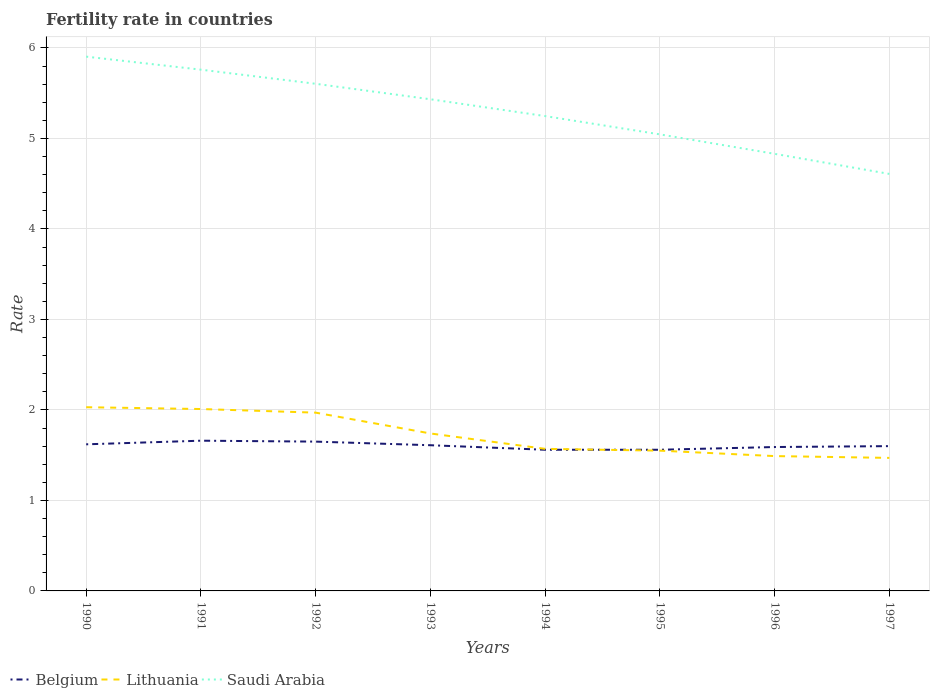How many different coloured lines are there?
Your response must be concise. 3. Across all years, what is the maximum fertility rate in Lithuania?
Your answer should be compact. 1.47. What is the total fertility rate in Saudi Arabia in the graph?
Make the answer very short. 0.47. What is the difference between the highest and the second highest fertility rate in Lithuania?
Your answer should be compact. 0.56. Is the fertility rate in Saudi Arabia strictly greater than the fertility rate in Lithuania over the years?
Your answer should be compact. No. How many years are there in the graph?
Provide a short and direct response. 8. Does the graph contain grids?
Provide a short and direct response. Yes. Where does the legend appear in the graph?
Provide a succinct answer. Bottom left. How are the legend labels stacked?
Provide a succinct answer. Horizontal. What is the title of the graph?
Your answer should be compact. Fertility rate in countries. What is the label or title of the Y-axis?
Give a very brief answer. Rate. What is the Rate of Belgium in 1990?
Your answer should be very brief. 1.62. What is the Rate in Lithuania in 1990?
Provide a short and direct response. 2.03. What is the Rate of Saudi Arabia in 1990?
Your response must be concise. 5.9. What is the Rate of Belgium in 1991?
Offer a terse response. 1.66. What is the Rate in Lithuania in 1991?
Your answer should be compact. 2.01. What is the Rate of Saudi Arabia in 1991?
Your answer should be very brief. 5.76. What is the Rate in Belgium in 1992?
Your answer should be very brief. 1.65. What is the Rate in Lithuania in 1992?
Keep it short and to the point. 1.97. What is the Rate in Saudi Arabia in 1992?
Ensure brevity in your answer.  5.6. What is the Rate in Belgium in 1993?
Make the answer very short. 1.61. What is the Rate of Lithuania in 1993?
Keep it short and to the point. 1.74. What is the Rate in Saudi Arabia in 1993?
Provide a short and direct response. 5.43. What is the Rate in Belgium in 1994?
Offer a very short reply. 1.56. What is the Rate in Lithuania in 1994?
Your answer should be compact. 1.57. What is the Rate in Saudi Arabia in 1994?
Your answer should be compact. 5.25. What is the Rate in Belgium in 1995?
Offer a terse response. 1.56. What is the Rate of Lithuania in 1995?
Provide a succinct answer. 1.55. What is the Rate of Saudi Arabia in 1995?
Provide a short and direct response. 5.04. What is the Rate of Belgium in 1996?
Offer a terse response. 1.59. What is the Rate of Lithuania in 1996?
Your answer should be very brief. 1.49. What is the Rate in Saudi Arabia in 1996?
Offer a terse response. 4.83. What is the Rate in Lithuania in 1997?
Give a very brief answer. 1.47. What is the Rate of Saudi Arabia in 1997?
Offer a very short reply. 4.61. Across all years, what is the maximum Rate in Belgium?
Make the answer very short. 1.66. Across all years, what is the maximum Rate of Lithuania?
Offer a very short reply. 2.03. Across all years, what is the maximum Rate of Saudi Arabia?
Make the answer very short. 5.9. Across all years, what is the minimum Rate of Belgium?
Ensure brevity in your answer.  1.56. Across all years, what is the minimum Rate of Lithuania?
Give a very brief answer. 1.47. Across all years, what is the minimum Rate of Saudi Arabia?
Offer a terse response. 4.61. What is the total Rate in Belgium in the graph?
Make the answer very short. 12.85. What is the total Rate of Lithuania in the graph?
Offer a very short reply. 13.83. What is the total Rate in Saudi Arabia in the graph?
Your answer should be compact. 42.43. What is the difference between the Rate in Belgium in 1990 and that in 1991?
Provide a short and direct response. -0.04. What is the difference between the Rate of Saudi Arabia in 1990 and that in 1991?
Offer a terse response. 0.14. What is the difference between the Rate of Belgium in 1990 and that in 1992?
Provide a succinct answer. -0.03. What is the difference between the Rate of Lithuania in 1990 and that in 1992?
Offer a very short reply. 0.06. What is the difference between the Rate in Belgium in 1990 and that in 1993?
Give a very brief answer. 0.01. What is the difference between the Rate in Lithuania in 1990 and that in 1993?
Offer a terse response. 0.29. What is the difference between the Rate in Saudi Arabia in 1990 and that in 1993?
Provide a short and direct response. 0.47. What is the difference between the Rate in Belgium in 1990 and that in 1994?
Provide a succinct answer. 0.06. What is the difference between the Rate of Lithuania in 1990 and that in 1994?
Give a very brief answer. 0.46. What is the difference between the Rate in Saudi Arabia in 1990 and that in 1994?
Provide a short and direct response. 0.66. What is the difference between the Rate in Belgium in 1990 and that in 1995?
Offer a terse response. 0.06. What is the difference between the Rate in Lithuania in 1990 and that in 1995?
Make the answer very short. 0.48. What is the difference between the Rate of Saudi Arabia in 1990 and that in 1995?
Offer a very short reply. 0.86. What is the difference between the Rate of Lithuania in 1990 and that in 1996?
Your answer should be very brief. 0.54. What is the difference between the Rate in Saudi Arabia in 1990 and that in 1996?
Your response must be concise. 1.07. What is the difference between the Rate of Lithuania in 1990 and that in 1997?
Provide a short and direct response. 0.56. What is the difference between the Rate of Saudi Arabia in 1990 and that in 1997?
Give a very brief answer. 1.3. What is the difference between the Rate in Belgium in 1991 and that in 1992?
Give a very brief answer. 0.01. What is the difference between the Rate of Saudi Arabia in 1991 and that in 1992?
Your answer should be very brief. 0.16. What is the difference between the Rate in Lithuania in 1991 and that in 1993?
Offer a terse response. 0.27. What is the difference between the Rate in Saudi Arabia in 1991 and that in 1993?
Your response must be concise. 0.33. What is the difference between the Rate in Belgium in 1991 and that in 1994?
Offer a terse response. 0.1. What is the difference between the Rate of Lithuania in 1991 and that in 1994?
Ensure brevity in your answer.  0.44. What is the difference between the Rate of Saudi Arabia in 1991 and that in 1994?
Ensure brevity in your answer.  0.51. What is the difference between the Rate in Belgium in 1991 and that in 1995?
Provide a succinct answer. 0.1. What is the difference between the Rate of Lithuania in 1991 and that in 1995?
Give a very brief answer. 0.46. What is the difference between the Rate of Saudi Arabia in 1991 and that in 1995?
Your response must be concise. 0.71. What is the difference between the Rate of Belgium in 1991 and that in 1996?
Your response must be concise. 0.07. What is the difference between the Rate in Lithuania in 1991 and that in 1996?
Offer a terse response. 0.52. What is the difference between the Rate in Saudi Arabia in 1991 and that in 1996?
Make the answer very short. 0.93. What is the difference between the Rate of Lithuania in 1991 and that in 1997?
Offer a terse response. 0.54. What is the difference between the Rate in Saudi Arabia in 1991 and that in 1997?
Offer a terse response. 1.15. What is the difference between the Rate of Belgium in 1992 and that in 1993?
Your response must be concise. 0.04. What is the difference between the Rate in Lithuania in 1992 and that in 1993?
Ensure brevity in your answer.  0.23. What is the difference between the Rate of Saudi Arabia in 1992 and that in 1993?
Offer a terse response. 0.17. What is the difference between the Rate of Belgium in 1992 and that in 1994?
Offer a very short reply. 0.09. What is the difference between the Rate in Lithuania in 1992 and that in 1994?
Your response must be concise. 0.4. What is the difference between the Rate in Saudi Arabia in 1992 and that in 1994?
Offer a terse response. 0.36. What is the difference between the Rate of Belgium in 1992 and that in 1995?
Give a very brief answer. 0.09. What is the difference between the Rate of Lithuania in 1992 and that in 1995?
Keep it short and to the point. 0.42. What is the difference between the Rate of Saudi Arabia in 1992 and that in 1995?
Provide a short and direct response. 0.56. What is the difference between the Rate of Belgium in 1992 and that in 1996?
Offer a terse response. 0.06. What is the difference between the Rate of Lithuania in 1992 and that in 1996?
Your answer should be compact. 0.48. What is the difference between the Rate of Saudi Arabia in 1992 and that in 1996?
Offer a terse response. 0.77. What is the difference between the Rate of Lithuania in 1992 and that in 1997?
Your answer should be very brief. 0.5. What is the difference between the Rate of Lithuania in 1993 and that in 1994?
Your answer should be compact. 0.17. What is the difference between the Rate in Saudi Arabia in 1993 and that in 1994?
Your response must be concise. 0.19. What is the difference between the Rate in Lithuania in 1993 and that in 1995?
Offer a very short reply. 0.19. What is the difference between the Rate in Saudi Arabia in 1993 and that in 1995?
Keep it short and to the point. 0.39. What is the difference between the Rate in Lithuania in 1993 and that in 1996?
Keep it short and to the point. 0.25. What is the difference between the Rate in Saudi Arabia in 1993 and that in 1996?
Give a very brief answer. 0.6. What is the difference between the Rate in Lithuania in 1993 and that in 1997?
Make the answer very short. 0.27. What is the difference between the Rate of Saudi Arabia in 1993 and that in 1997?
Make the answer very short. 0.82. What is the difference between the Rate in Lithuania in 1994 and that in 1995?
Your response must be concise. 0.02. What is the difference between the Rate in Saudi Arabia in 1994 and that in 1995?
Your answer should be very brief. 0.2. What is the difference between the Rate of Belgium in 1994 and that in 1996?
Ensure brevity in your answer.  -0.03. What is the difference between the Rate of Lithuania in 1994 and that in 1996?
Your response must be concise. 0.08. What is the difference between the Rate of Saudi Arabia in 1994 and that in 1996?
Offer a very short reply. 0.42. What is the difference between the Rate in Belgium in 1994 and that in 1997?
Offer a terse response. -0.04. What is the difference between the Rate of Saudi Arabia in 1994 and that in 1997?
Provide a short and direct response. 0.64. What is the difference between the Rate of Belgium in 1995 and that in 1996?
Offer a terse response. -0.03. What is the difference between the Rate of Saudi Arabia in 1995 and that in 1996?
Keep it short and to the point. 0.21. What is the difference between the Rate in Belgium in 1995 and that in 1997?
Ensure brevity in your answer.  -0.04. What is the difference between the Rate in Lithuania in 1995 and that in 1997?
Offer a very short reply. 0.08. What is the difference between the Rate in Saudi Arabia in 1995 and that in 1997?
Make the answer very short. 0.44. What is the difference between the Rate of Belgium in 1996 and that in 1997?
Offer a terse response. -0.01. What is the difference between the Rate in Lithuania in 1996 and that in 1997?
Your answer should be compact. 0.02. What is the difference between the Rate of Saudi Arabia in 1996 and that in 1997?
Offer a very short reply. 0.22. What is the difference between the Rate in Belgium in 1990 and the Rate in Lithuania in 1991?
Make the answer very short. -0.39. What is the difference between the Rate of Belgium in 1990 and the Rate of Saudi Arabia in 1991?
Provide a succinct answer. -4.14. What is the difference between the Rate of Lithuania in 1990 and the Rate of Saudi Arabia in 1991?
Give a very brief answer. -3.73. What is the difference between the Rate of Belgium in 1990 and the Rate of Lithuania in 1992?
Make the answer very short. -0.35. What is the difference between the Rate of Belgium in 1990 and the Rate of Saudi Arabia in 1992?
Your answer should be compact. -3.98. What is the difference between the Rate of Lithuania in 1990 and the Rate of Saudi Arabia in 1992?
Offer a very short reply. -3.57. What is the difference between the Rate in Belgium in 1990 and the Rate in Lithuania in 1993?
Your answer should be compact. -0.12. What is the difference between the Rate in Belgium in 1990 and the Rate in Saudi Arabia in 1993?
Provide a succinct answer. -3.81. What is the difference between the Rate in Lithuania in 1990 and the Rate in Saudi Arabia in 1993?
Your answer should be very brief. -3.4. What is the difference between the Rate in Belgium in 1990 and the Rate in Lithuania in 1994?
Make the answer very short. 0.05. What is the difference between the Rate in Belgium in 1990 and the Rate in Saudi Arabia in 1994?
Keep it short and to the point. -3.63. What is the difference between the Rate in Lithuania in 1990 and the Rate in Saudi Arabia in 1994?
Provide a short and direct response. -3.22. What is the difference between the Rate of Belgium in 1990 and the Rate of Lithuania in 1995?
Provide a short and direct response. 0.07. What is the difference between the Rate of Belgium in 1990 and the Rate of Saudi Arabia in 1995?
Keep it short and to the point. -3.42. What is the difference between the Rate in Lithuania in 1990 and the Rate in Saudi Arabia in 1995?
Your answer should be compact. -3.02. What is the difference between the Rate in Belgium in 1990 and the Rate in Lithuania in 1996?
Offer a terse response. 0.13. What is the difference between the Rate in Belgium in 1990 and the Rate in Saudi Arabia in 1996?
Offer a very short reply. -3.21. What is the difference between the Rate of Belgium in 1990 and the Rate of Saudi Arabia in 1997?
Your answer should be very brief. -2.99. What is the difference between the Rate in Lithuania in 1990 and the Rate in Saudi Arabia in 1997?
Offer a terse response. -2.58. What is the difference between the Rate of Belgium in 1991 and the Rate of Lithuania in 1992?
Ensure brevity in your answer.  -0.31. What is the difference between the Rate of Belgium in 1991 and the Rate of Saudi Arabia in 1992?
Provide a short and direct response. -3.94. What is the difference between the Rate in Lithuania in 1991 and the Rate in Saudi Arabia in 1992?
Your answer should be compact. -3.59. What is the difference between the Rate of Belgium in 1991 and the Rate of Lithuania in 1993?
Your answer should be very brief. -0.08. What is the difference between the Rate of Belgium in 1991 and the Rate of Saudi Arabia in 1993?
Your answer should be compact. -3.77. What is the difference between the Rate in Lithuania in 1991 and the Rate in Saudi Arabia in 1993?
Keep it short and to the point. -3.42. What is the difference between the Rate in Belgium in 1991 and the Rate in Lithuania in 1994?
Keep it short and to the point. 0.09. What is the difference between the Rate of Belgium in 1991 and the Rate of Saudi Arabia in 1994?
Keep it short and to the point. -3.59. What is the difference between the Rate in Lithuania in 1991 and the Rate in Saudi Arabia in 1994?
Ensure brevity in your answer.  -3.24. What is the difference between the Rate in Belgium in 1991 and the Rate in Lithuania in 1995?
Your answer should be very brief. 0.11. What is the difference between the Rate in Belgium in 1991 and the Rate in Saudi Arabia in 1995?
Offer a very short reply. -3.38. What is the difference between the Rate in Lithuania in 1991 and the Rate in Saudi Arabia in 1995?
Your answer should be compact. -3.04. What is the difference between the Rate of Belgium in 1991 and the Rate of Lithuania in 1996?
Your answer should be very brief. 0.17. What is the difference between the Rate of Belgium in 1991 and the Rate of Saudi Arabia in 1996?
Your answer should be compact. -3.17. What is the difference between the Rate of Lithuania in 1991 and the Rate of Saudi Arabia in 1996?
Ensure brevity in your answer.  -2.82. What is the difference between the Rate in Belgium in 1991 and the Rate in Lithuania in 1997?
Your response must be concise. 0.19. What is the difference between the Rate in Belgium in 1991 and the Rate in Saudi Arabia in 1997?
Keep it short and to the point. -2.95. What is the difference between the Rate in Lithuania in 1991 and the Rate in Saudi Arabia in 1997?
Offer a very short reply. -2.6. What is the difference between the Rate of Belgium in 1992 and the Rate of Lithuania in 1993?
Offer a terse response. -0.09. What is the difference between the Rate in Belgium in 1992 and the Rate in Saudi Arabia in 1993?
Ensure brevity in your answer.  -3.78. What is the difference between the Rate in Lithuania in 1992 and the Rate in Saudi Arabia in 1993?
Offer a very short reply. -3.46. What is the difference between the Rate in Belgium in 1992 and the Rate in Saudi Arabia in 1994?
Your answer should be very brief. -3.6. What is the difference between the Rate in Lithuania in 1992 and the Rate in Saudi Arabia in 1994?
Your response must be concise. -3.28. What is the difference between the Rate of Belgium in 1992 and the Rate of Lithuania in 1995?
Your response must be concise. 0.1. What is the difference between the Rate of Belgium in 1992 and the Rate of Saudi Arabia in 1995?
Give a very brief answer. -3.4. What is the difference between the Rate of Lithuania in 1992 and the Rate of Saudi Arabia in 1995?
Offer a very short reply. -3.08. What is the difference between the Rate in Belgium in 1992 and the Rate in Lithuania in 1996?
Give a very brief answer. 0.16. What is the difference between the Rate in Belgium in 1992 and the Rate in Saudi Arabia in 1996?
Provide a succinct answer. -3.18. What is the difference between the Rate in Lithuania in 1992 and the Rate in Saudi Arabia in 1996?
Your answer should be very brief. -2.86. What is the difference between the Rate in Belgium in 1992 and the Rate in Lithuania in 1997?
Your answer should be compact. 0.18. What is the difference between the Rate in Belgium in 1992 and the Rate in Saudi Arabia in 1997?
Provide a succinct answer. -2.96. What is the difference between the Rate of Lithuania in 1992 and the Rate of Saudi Arabia in 1997?
Ensure brevity in your answer.  -2.64. What is the difference between the Rate in Belgium in 1993 and the Rate in Lithuania in 1994?
Ensure brevity in your answer.  0.04. What is the difference between the Rate in Belgium in 1993 and the Rate in Saudi Arabia in 1994?
Your answer should be very brief. -3.64. What is the difference between the Rate of Lithuania in 1993 and the Rate of Saudi Arabia in 1994?
Your answer should be very brief. -3.51. What is the difference between the Rate in Belgium in 1993 and the Rate in Saudi Arabia in 1995?
Your answer should be very brief. -3.44. What is the difference between the Rate in Lithuania in 1993 and the Rate in Saudi Arabia in 1995?
Give a very brief answer. -3.31. What is the difference between the Rate of Belgium in 1993 and the Rate of Lithuania in 1996?
Your answer should be compact. 0.12. What is the difference between the Rate of Belgium in 1993 and the Rate of Saudi Arabia in 1996?
Provide a succinct answer. -3.22. What is the difference between the Rate of Lithuania in 1993 and the Rate of Saudi Arabia in 1996?
Give a very brief answer. -3.09. What is the difference between the Rate of Belgium in 1993 and the Rate of Lithuania in 1997?
Your answer should be very brief. 0.14. What is the difference between the Rate of Belgium in 1993 and the Rate of Saudi Arabia in 1997?
Offer a very short reply. -3. What is the difference between the Rate of Lithuania in 1993 and the Rate of Saudi Arabia in 1997?
Your response must be concise. -2.87. What is the difference between the Rate in Belgium in 1994 and the Rate in Saudi Arabia in 1995?
Make the answer very short. -3.48. What is the difference between the Rate of Lithuania in 1994 and the Rate of Saudi Arabia in 1995?
Your response must be concise. -3.48. What is the difference between the Rate of Belgium in 1994 and the Rate of Lithuania in 1996?
Make the answer very short. 0.07. What is the difference between the Rate of Belgium in 1994 and the Rate of Saudi Arabia in 1996?
Provide a short and direct response. -3.27. What is the difference between the Rate of Lithuania in 1994 and the Rate of Saudi Arabia in 1996?
Your answer should be very brief. -3.26. What is the difference between the Rate in Belgium in 1994 and the Rate in Lithuania in 1997?
Provide a short and direct response. 0.09. What is the difference between the Rate in Belgium in 1994 and the Rate in Saudi Arabia in 1997?
Your answer should be very brief. -3.05. What is the difference between the Rate of Lithuania in 1994 and the Rate of Saudi Arabia in 1997?
Your answer should be compact. -3.04. What is the difference between the Rate in Belgium in 1995 and the Rate in Lithuania in 1996?
Provide a succinct answer. 0.07. What is the difference between the Rate in Belgium in 1995 and the Rate in Saudi Arabia in 1996?
Your answer should be compact. -3.27. What is the difference between the Rate in Lithuania in 1995 and the Rate in Saudi Arabia in 1996?
Provide a succinct answer. -3.28. What is the difference between the Rate of Belgium in 1995 and the Rate of Lithuania in 1997?
Give a very brief answer. 0.09. What is the difference between the Rate in Belgium in 1995 and the Rate in Saudi Arabia in 1997?
Provide a short and direct response. -3.05. What is the difference between the Rate in Lithuania in 1995 and the Rate in Saudi Arabia in 1997?
Offer a terse response. -3.06. What is the difference between the Rate in Belgium in 1996 and the Rate in Lithuania in 1997?
Your answer should be very brief. 0.12. What is the difference between the Rate of Belgium in 1996 and the Rate of Saudi Arabia in 1997?
Provide a short and direct response. -3.02. What is the difference between the Rate in Lithuania in 1996 and the Rate in Saudi Arabia in 1997?
Offer a terse response. -3.12. What is the average Rate of Belgium per year?
Offer a terse response. 1.61. What is the average Rate in Lithuania per year?
Make the answer very short. 1.73. What is the average Rate in Saudi Arabia per year?
Make the answer very short. 5.3. In the year 1990, what is the difference between the Rate of Belgium and Rate of Lithuania?
Make the answer very short. -0.41. In the year 1990, what is the difference between the Rate of Belgium and Rate of Saudi Arabia?
Provide a short and direct response. -4.28. In the year 1990, what is the difference between the Rate of Lithuania and Rate of Saudi Arabia?
Provide a short and direct response. -3.87. In the year 1991, what is the difference between the Rate in Belgium and Rate in Lithuania?
Ensure brevity in your answer.  -0.35. In the year 1991, what is the difference between the Rate of Lithuania and Rate of Saudi Arabia?
Ensure brevity in your answer.  -3.75. In the year 1992, what is the difference between the Rate of Belgium and Rate of Lithuania?
Offer a terse response. -0.32. In the year 1992, what is the difference between the Rate in Belgium and Rate in Saudi Arabia?
Provide a succinct answer. -3.95. In the year 1992, what is the difference between the Rate of Lithuania and Rate of Saudi Arabia?
Your answer should be very brief. -3.63. In the year 1993, what is the difference between the Rate in Belgium and Rate in Lithuania?
Make the answer very short. -0.13. In the year 1993, what is the difference between the Rate of Belgium and Rate of Saudi Arabia?
Your answer should be very brief. -3.82. In the year 1993, what is the difference between the Rate of Lithuania and Rate of Saudi Arabia?
Provide a succinct answer. -3.69. In the year 1994, what is the difference between the Rate of Belgium and Rate of Lithuania?
Your answer should be very brief. -0.01. In the year 1994, what is the difference between the Rate of Belgium and Rate of Saudi Arabia?
Make the answer very short. -3.69. In the year 1994, what is the difference between the Rate in Lithuania and Rate in Saudi Arabia?
Offer a terse response. -3.68. In the year 1995, what is the difference between the Rate of Belgium and Rate of Saudi Arabia?
Offer a terse response. -3.48. In the year 1995, what is the difference between the Rate of Lithuania and Rate of Saudi Arabia?
Make the answer very short. -3.5. In the year 1996, what is the difference between the Rate of Belgium and Rate of Lithuania?
Provide a succinct answer. 0.1. In the year 1996, what is the difference between the Rate of Belgium and Rate of Saudi Arabia?
Give a very brief answer. -3.24. In the year 1996, what is the difference between the Rate in Lithuania and Rate in Saudi Arabia?
Your answer should be very brief. -3.34. In the year 1997, what is the difference between the Rate in Belgium and Rate in Lithuania?
Provide a short and direct response. 0.13. In the year 1997, what is the difference between the Rate in Belgium and Rate in Saudi Arabia?
Your answer should be very brief. -3.01. In the year 1997, what is the difference between the Rate in Lithuania and Rate in Saudi Arabia?
Offer a very short reply. -3.14. What is the ratio of the Rate in Belgium in 1990 to that in 1991?
Your answer should be very brief. 0.98. What is the ratio of the Rate in Lithuania in 1990 to that in 1991?
Your answer should be very brief. 1.01. What is the ratio of the Rate in Saudi Arabia in 1990 to that in 1991?
Give a very brief answer. 1.02. What is the ratio of the Rate of Belgium in 1990 to that in 1992?
Your answer should be compact. 0.98. What is the ratio of the Rate in Lithuania in 1990 to that in 1992?
Provide a succinct answer. 1.03. What is the ratio of the Rate in Saudi Arabia in 1990 to that in 1992?
Keep it short and to the point. 1.05. What is the ratio of the Rate of Belgium in 1990 to that in 1993?
Offer a very short reply. 1.01. What is the ratio of the Rate of Lithuania in 1990 to that in 1993?
Your answer should be very brief. 1.17. What is the ratio of the Rate of Saudi Arabia in 1990 to that in 1993?
Your answer should be very brief. 1.09. What is the ratio of the Rate of Belgium in 1990 to that in 1994?
Your answer should be compact. 1.04. What is the ratio of the Rate in Lithuania in 1990 to that in 1994?
Make the answer very short. 1.29. What is the ratio of the Rate of Saudi Arabia in 1990 to that in 1994?
Keep it short and to the point. 1.13. What is the ratio of the Rate in Lithuania in 1990 to that in 1995?
Offer a terse response. 1.31. What is the ratio of the Rate of Saudi Arabia in 1990 to that in 1995?
Provide a succinct answer. 1.17. What is the ratio of the Rate of Belgium in 1990 to that in 1996?
Provide a succinct answer. 1.02. What is the ratio of the Rate of Lithuania in 1990 to that in 1996?
Make the answer very short. 1.36. What is the ratio of the Rate in Saudi Arabia in 1990 to that in 1996?
Your answer should be compact. 1.22. What is the ratio of the Rate of Belgium in 1990 to that in 1997?
Your answer should be compact. 1.01. What is the ratio of the Rate of Lithuania in 1990 to that in 1997?
Ensure brevity in your answer.  1.38. What is the ratio of the Rate of Saudi Arabia in 1990 to that in 1997?
Your answer should be compact. 1.28. What is the ratio of the Rate of Belgium in 1991 to that in 1992?
Your answer should be compact. 1.01. What is the ratio of the Rate of Lithuania in 1991 to that in 1992?
Offer a very short reply. 1.02. What is the ratio of the Rate in Saudi Arabia in 1991 to that in 1992?
Your answer should be very brief. 1.03. What is the ratio of the Rate of Belgium in 1991 to that in 1993?
Offer a very short reply. 1.03. What is the ratio of the Rate of Lithuania in 1991 to that in 1993?
Give a very brief answer. 1.16. What is the ratio of the Rate in Saudi Arabia in 1991 to that in 1993?
Make the answer very short. 1.06. What is the ratio of the Rate in Belgium in 1991 to that in 1994?
Provide a succinct answer. 1.06. What is the ratio of the Rate of Lithuania in 1991 to that in 1994?
Keep it short and to the point. 1.28. What is the ratio of the Rate of Saudi Arabia in 1991 to that in 1994?
Provide a succinct answer. 1.1. What is the ratio of the Rate of Belgium in 1991 to that in 1995?
Offer a terse response. 1.06. What is the ratio of the Rate in Lithuania in 1991 to that in 1995?
Ensure brevity in your answer.  1.3. What is the ratio of the Rate of Saudi Arabia in 1991 to that in 1995?
Your answer should be very brief. 1.14. What is the ratio of the Rate in Belgium in 1991 to that in 1996?
Your answer should be very brief. 1.04. What is the ratio of the Rate in Lithuania in 1991 to that in 1996?
Your answer should be compact. 1.35. What is the ratio of the Rate of Saudi Arabia in 1991 to that in 1996?
Provide a succinct answer. 1.19. What is the ratio of the Rate of Belgium in 1991 to that in 1997?
Give a very brief answer. 1.04. What is the ratio of the Rate of Lithuania in 1991 to that in 1997?
Your answer should be very brief. 1.37. What is the ratio of the Rate of Saudi Arabia in 1991 to that in 1997?
Ensure brevity in your answer.  1.25. What is the ratio of the Rate in Belgium in 1992 to that in 1993?
Ensure brevity in your answer.  1.02. What is the ratio of the Rate in Lithuania in 1992 to that in 1993?
Offer a terse response. 1.13. What is the ratio of the Rate of Saudi Arabia in 1992 to that in 1993?
Offer a very short reply. 1.03. What is the ratio of the Rate in Belgium in 1992 to that in 1994?
Your answer should be compact. 1.06. What is the ratio of the Rate in Lithuania in 1992 to that in 1994?
Offer a terse response. 1.25. What is the ratio of the Rate in Saudi Arabia in 1992 to that in 1994?
Provide a short and direct response. 1.07. What is the ratio of the Rate of Belgium in 1992 to that in 1995?
Keep it short and to the point. 1.06. What is the ratio of the Rate of Lithuania in 1992 to that in 1995?
Make the answer very short. 1.27. What is the ratio of the Rate in Saudi Arabia in 1992 to that in 1995?
Keep it short and to the point. 1.11. What is the ratio of the Rate in Belgium in 1992 to that in 1996?
Keep it short and to the point. 1.04. What is the ratio of the Rate in Lithuania in 1992 to that in 1996?
Your response must be concise. 1.32. What is the ratio of the Rate of Saudi Arabia in 1992 to that in 1996?
Offer a very short reply. 1.16. What is the ratio of the Rate of Belgium in 1992 to that in 1997?
Provide a short and direct response. 1.03. What is the ratio of the Rate of Lithuania in 1992 to that in 1997?
Ensure brevity in your answer.  1.34. What is the ratio of the Rate of Saudi Arabia in 1992 to that in 1997?
Provide a short and direct response. 1.22. What is the ratio of the Rate in Belgium in 1993 to that in 1994?
Keep it short and to the point. 1.03. What is the ratio of the Rate of Lithuania in 1993 to that in 1994?
Give a very brief answer. 1.11. What is the ratio of the Rate in Saudi Arabia in 1993 to that in 1994?
Offer a terse response. 1.04. What is the ratio of the Rate in Belgium in 1993 to that in 1995?
Make the answer very short. 1.03. What is the ratio of the Rate in Lithuania in 1993 to that in 1995?
Give a very brief answer. 1.12. What is the ratio of the Rate in Belgium in 1993 to that in 1996?
Provide a short and direct response. 1.01. What is the ratio of the Rate of Lithuania in 1993 to that in 1996?
Your answer should be very brief. 1.17. What is the ratio of the Rate in Saudi Arabia in 1993 to that in 1996?
Offer a very short reply. 1.12. What is the ratio of the Rate of Belgium in 1993 to that in 1997?
Provide a short and direct response. 1.01. What is the ratio of the Rate in Lithuania in 1993 to that in 1997?
Ensure brevity in your answer.  1.18. What is the ratio of the Rate in Saudi Arabia in 1993 to that in 1997?
Offer a very short reply. 1.18. What is the ratio of the Rate in Lithuania in 1994 to that in 1995?
Offer a very short reply. 1.01. What is the ratio of the Rate of Saudi Arabia in 1994 to that in 1995?
Ensure brevity in your answer.  1.04. What is the ratio of the Rate of Belgium in 1994 to that in 1996?
Give a very brief answer. 0.98. What is the ratio of the Rate of Lithuania in 1994 to that in 1996?
Make the answer very short. 1.05. What is the ratio of the Rate of Saudi Arabia in 1994 to that in 1996?
Offer a terse response. 1.09. What is the ratio of the Rate in Lithuania in 1994 to that in 1997?
Ensure brevity in your answer.  1.07. What is the ratio of the Rate in Saudi Arabia in 1994 to that in 1997?
Provide a short and direct response. 1.14. What is the ratio of the Rate of Belgium in 1995 to that in 1996?
Offer a terse response. 0.98. What is the ratio of the Rate in Lithuania in 1995 to that in 1996?
Offer a very short reply. 1.04. What is the ratio of the Rate in Saudi Arabia in 1995 to that in 1996?
Provide a short and direct response. 1.04. What is the ratio of the Rate in Lithuania in 1995 to that in 1997?
Give a very brief answer. 1.05. What is the ratio of the Rate of Saudi Arabia in 1995 to that in 1997?
Your answer should be compact. 1.09. What is the ratio of the Rate of Belgium in 1996 to that in 1997?
Your answer should be very brief. 0.99. What is the ratio of the Rate of Lithuania in 1996 to that in 1997?
Give a very brief answer. 1.01. What is the ratio of the Rate in Saudi Arabia in 1996 to that in 1997?
Your answer should be very brief. 1.05. What is the difference between the highest and the second highest Rate in Saudi Arabia?
Make the answer very short. 0.14. What is the difference between the highest and the lowest Rate of Lithuania?
Your response must be concise. 0.56. What is the difference between the highest and the lowest Rate in Saudi Arabia?
Make the answer very short. 1.3. 